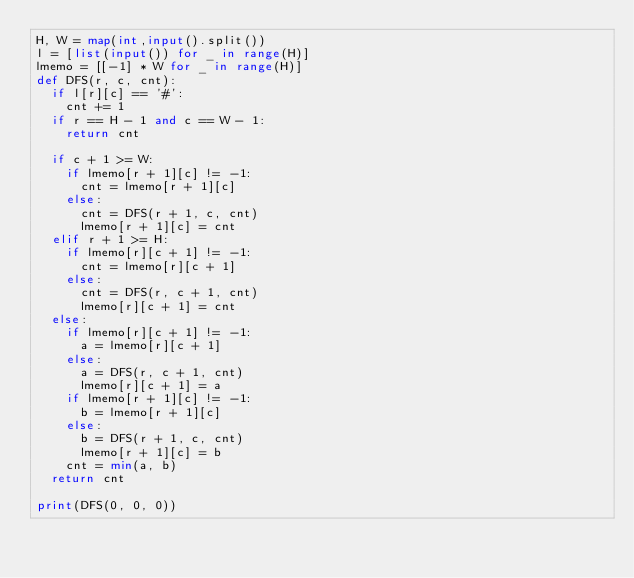Convert code to text. <code><loc_0><loc_0><loc_500><loc_500><_Python_>H, W = map(int,input().split())
l = [list(input()) for _ in range(H)]
lmemo = [[-1] * W for _ in range(H)]
def DFS(r, c, cnt):
  if l[r][c] == '#':
    cnt += 1
  if r == H - 1 and c == W - 1:
    return cnt
  
  if c + 1 >= W:
    if lmemo[r + 1][c] != -1:
      cnt = lmemo[r + 1][c]
    else:
      cnt = DFS(r + 1, c, cnt)
      lmemo[r + 1][c] = cnt
  elif r + 1 >= H:
    if lmemo[r][c + 1] != -1:
      cnt = lmemo[r][c + 1]
    else:
      cnt = DFS(r, c + 1, cnt)
      lmemo[r][c + 1] = cnt
  else:
    if lmemo[r][c + 1] != -1:
      a = lmemo[r][c + 1]
    else:
      a = DFS(r, c + 1, cnt)
      lmemo[r][c + 1] = a
    if lmemo[r + 1][c] != -1:
      b = lmemo[r + 1][c]
    else:
      b = DFS(r + 1, c, cnt)
      lmemo[r + 1][c] = b
    cnt = min(a, b)
  return cnt

print(DFS(0, 0, 0))
</code> 